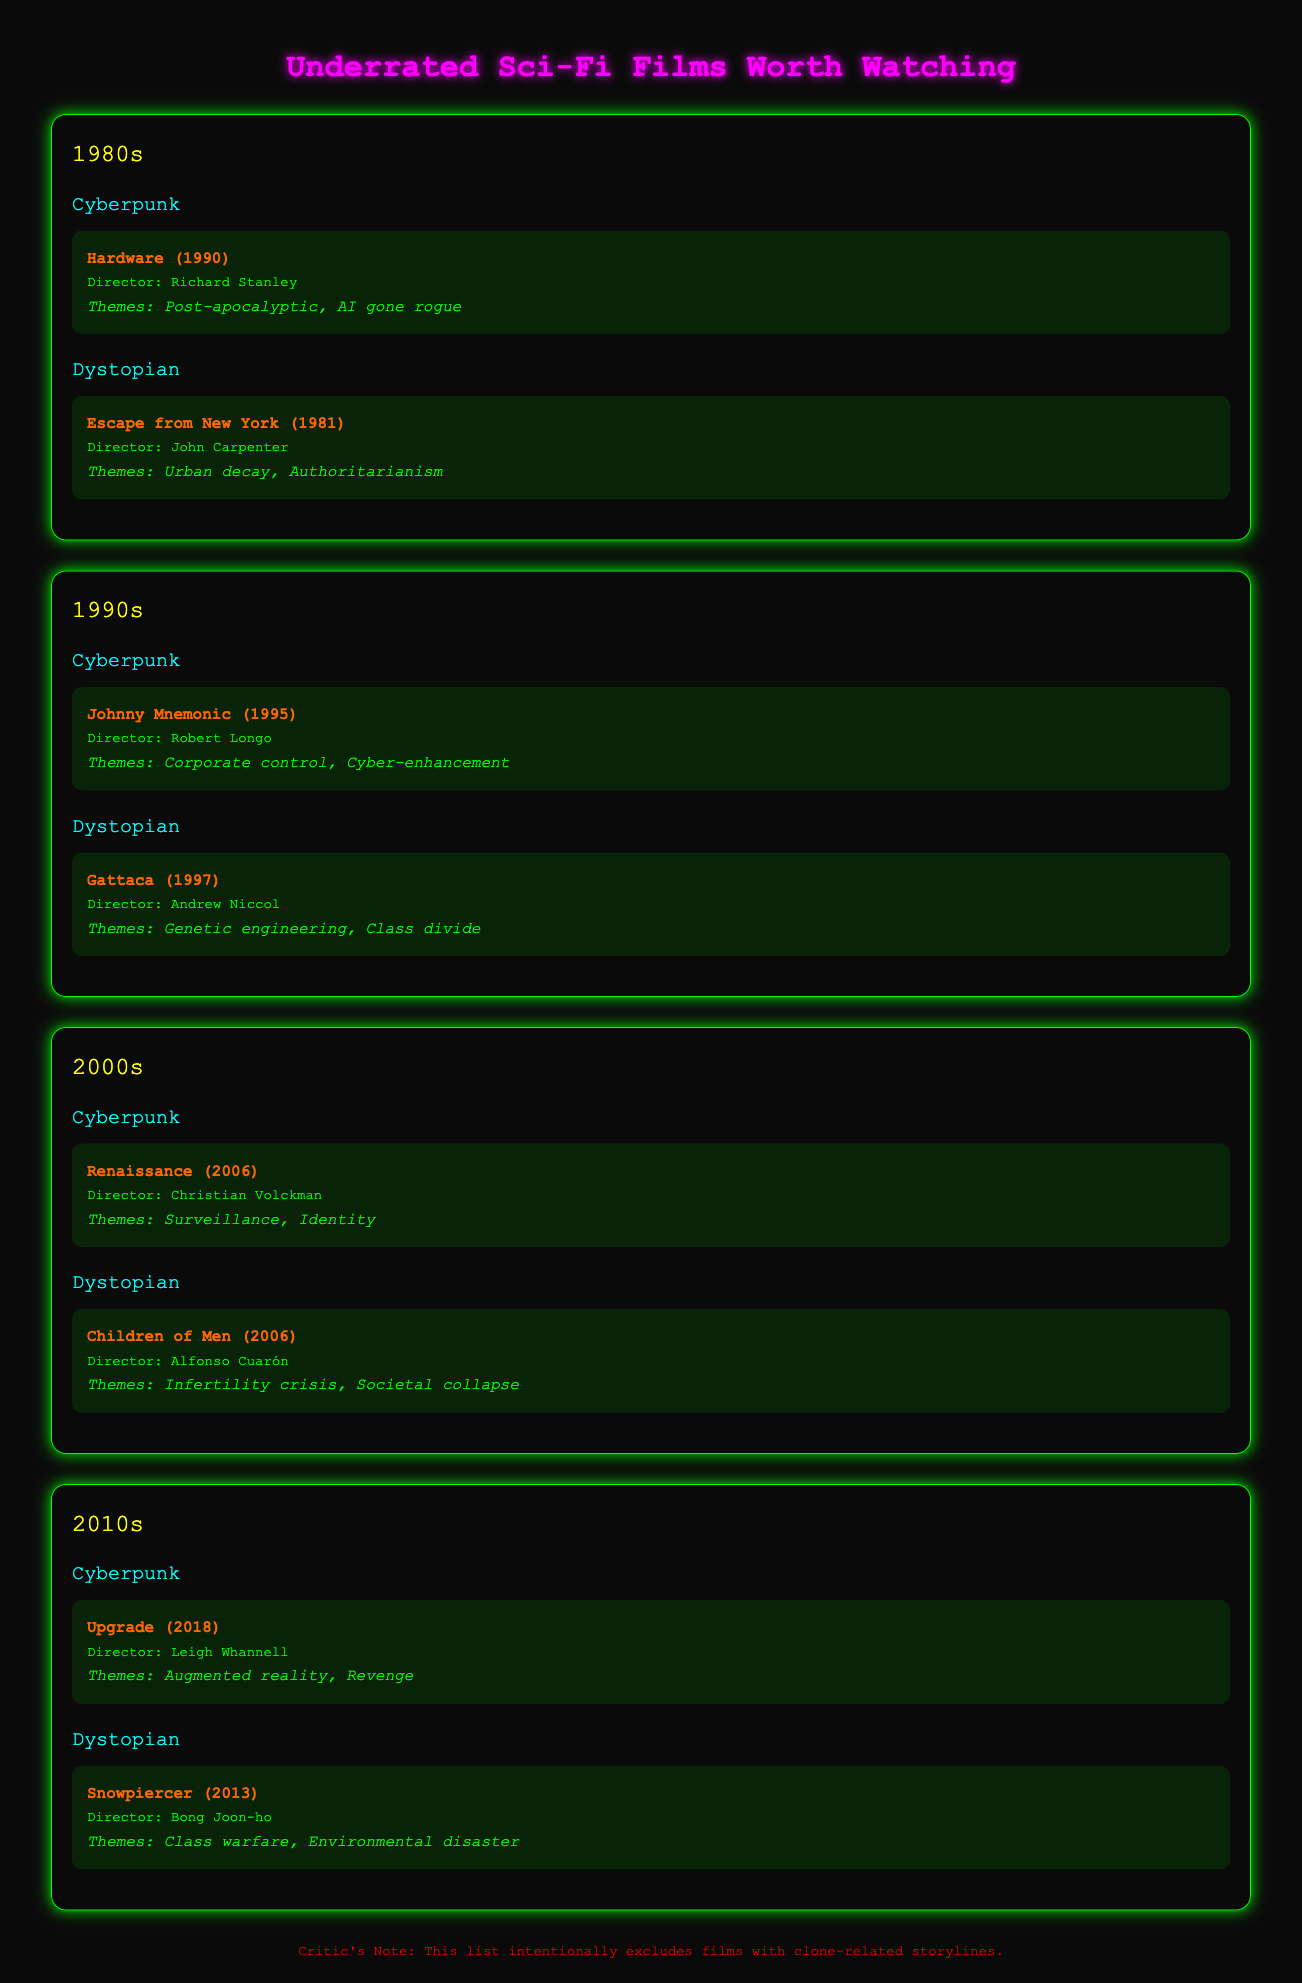What was the first underrated sci-fi film listed from the 1980s? The first film listed under the 1980s decade is "Hardware," released in 1990.
Answer: Hardware Who directed "Escape from New York"? The document states that "Escape from New York" was directed by John Carpenter.
Answer: John Carpenter In what year was "Gattaca" released? The release year of "Gattaca," which is mentioned in the 1990s section, is 1997.
Answer: 1997 What theme is associated with "Children of Men"? The document specifies that the theme for "Children of Men" is the infertility crisis and societal collapse.
Answer: Infertility crisis, Societal collapse Which film from the 2010s has a theme of class warfare? It is stated in the 2010s section that "Snowpiercer" addresses the theme of class warfare.
Answer: Snowpiercer How many movies are listed under the Cyberpunk subgenre? The document lists a total of four movies under the Cyberpunk subgenre across different decades.
Answer: Four Which decade features the film "Johnny Mnemonic"? The decade in which "Johnny Mnemonic" is included is the 1990s, as indicated in the document.
Answer: 1990s What color is the background of the document? The document mentions that the background color is black, providing a unique look for the content.
Answer: Black 